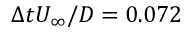<formula> <loc_0><loc_0><loc_500><loc_500>\Delta t U _ { \infty } / D = 0 . 0 7 2</formula> 